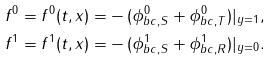<formula> <loc_0><loc_0><loc_500><loc_500>f ^ { 0 } = f ^ { 0 } ( t , x ) = & - ( \phi ^ { 0 } _ { b c , S } + \phi ^ { 0 } _ { b c , T } ) | _ { y = 1 } , \\ f ^ { 1 } = f ^ { 1 } ( t , x ) = & - ( \phi ^ { 1 } _ { b c , S } + \phi ^ { 1 } _ { b c , R } ) | _ { y = 0 } .</formula> 